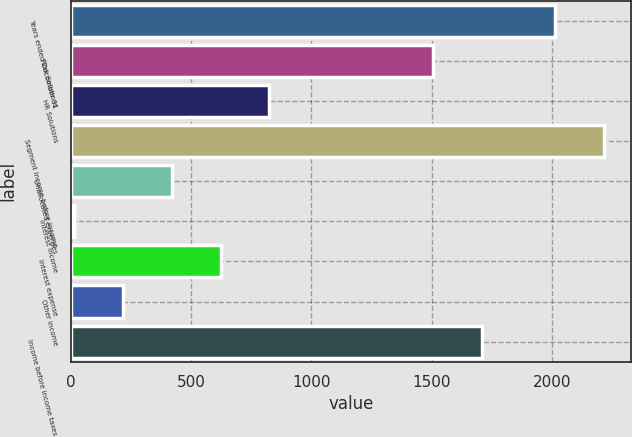Convert chart. <chart><loc_0><loc_0><loc_500><loc_500><bar_chart><fcel>Years ended December 31<fcel>Risk Solutions<fcel>HR Solutions<fcel>Segment income before income<fcel>Unallocated expenses<fcel>Interest income<fcel>Interest expense<fcel>Other income<fcel>Income before income taxes<nl><fcel>2015<fcel>1506<fcel>825.2<fcel>2217.8<fcel>419.6<fcel>14<fcel>622.4<fcel>216.8<fcel>1708.8<nl></chart> 